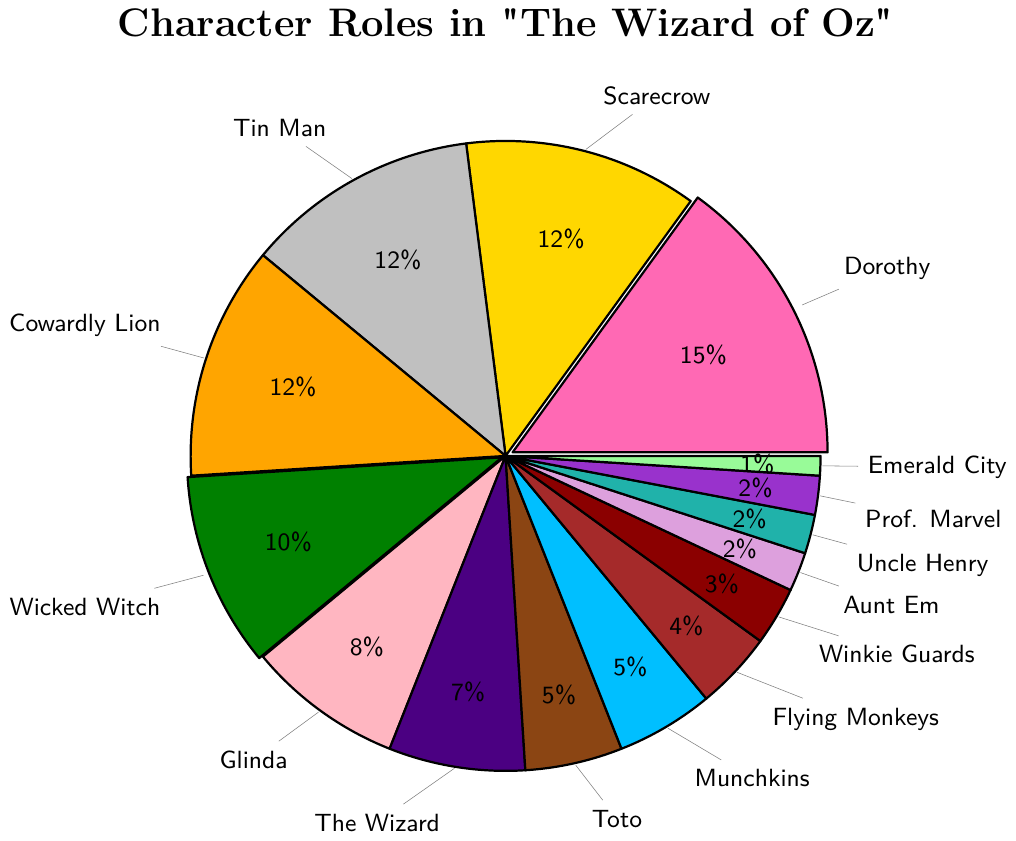Which character role makes up the largest proportion of the cast? The character with the highest percentage in the pie chart is Dorothy with 15%.
Answer: Dorothy How does the proportion of the Scarecrow compare to that of Tin Man and Cowardly Lion combined? The Scarecrow is 12%, while the combined percentage of Tin Man and Cowardly Lion is 12% + 12% = 24%. The Scarecrow's proportion is half that of Tin Man and Cowardly Lion combined.
Answer: Half What percentage of the cast do Glinda, The Wizard, and Toto contribute together? Summing the percentages for Glinda (8%), The Wizard (7%), and Toto (5%), we get 8% + 7% + 5% = 20%.
Answer: 20% Is the proportion of Flying Monkeys greater than that of the Munchkins? The Flying Monkeys make up 4% of the cast, while the Munchkins make up 5%. Therefore, the proportion of the Flying Monkeys is less than that of the Munchkins.
Answer: No What’s the combined proportion of the characters with 2% each? Adding the percentages for Aunt Em (2%), Uncle Henry (2%), and Professor Marvel (2%), we get 2% + 2% + 2% = 6%.
Answer: 6% Which characters have an equal proportion in the cast, and what is their percentage? The characters with equal proportions in the cast are Scarecrow, Tin Man, and Cowardly Lion, each having 12%.
Answer: Scarecrow, Tin Man, Cowardly Lion, 12% Which character role is represented by the smallest proportion of the cast? The role with the smallest proportion is Emerald City Citizens with 1%.
Answer: Emerald City Citizens How many of the character roles contribute more than 10% each? The roles contributing more than 10% are Dorothy, Scarecrow, Tin Man, and Cowardly Lion. There are 4 such roles.
Answer: 4 If we were to combine the roles of the Wicked Witch of the West and Glinda the Good Witch, what would their total proportion be? Adding the percentages for the Wicked Witch of the West (10%) and Glinda the Good Witch (8%), we get 10% + 8% = 18%.
Answer: 18% What is the median percentage value of the character roles? Ordering the percentages from smallest to largest (1, 2, 2, 2, 3, 4, 5, 5, 7, 8, 10, 12, 12, 12, 15), the middle value (8th value out of 15) is 5%.
Answer: 5% 